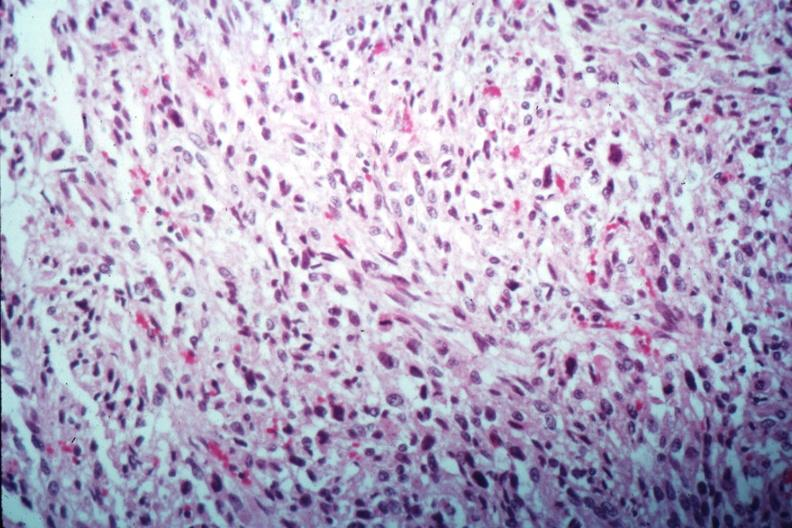s amyloidosis present?
Answer the question using a single word or phrase. No 